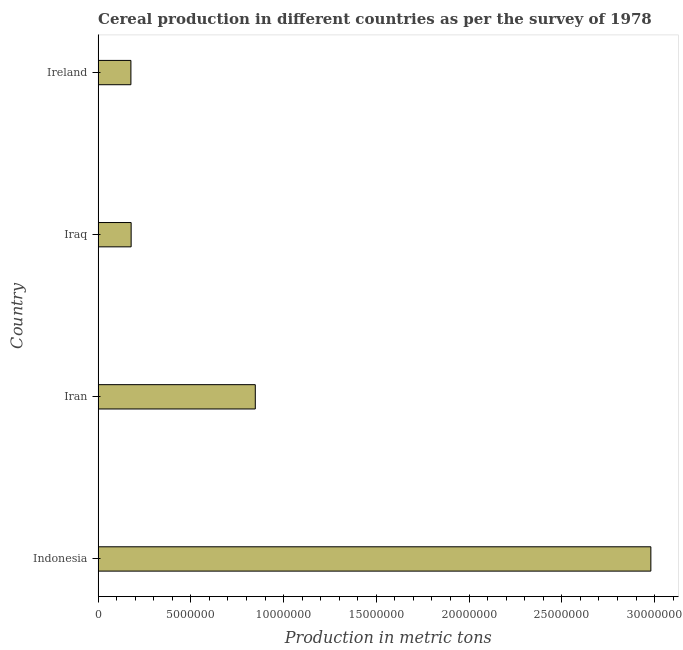Does the graph contain any zero values?
Make the answer very short. No. What is the title of the graph?
Make the answer very short. Cereal production in different countries as per the survey of 1978. What is the label or title of the X-axis?
Make the answer very short. Production in metric tons. What is the label or title of the Y-axis?
Give a very brief answer. Country. What is the cereal production in Ireland?
Offer a very short reply. 1.77e+06. Across all countries, what is the maximum cereal production?
Give a very brief answer. 2.98e+07. Across all countries, what is the minimum cereal production?
Offer a very short reply. 1.77e+06. In which country was the cereal production maximum?
Give a very brief answer. Indonesia. In which country was the cereal production minimum?
Give a very brief answer. Ireland. What is the sum of the cereal production?
Give a very brief answer. 4.18e+07. What is the difference between the cereal production in Iraq and Ireland?
Offer a terse response. 1.25e+04. What is the average cereal production per country?
Your answer should be compact. 1.05e+07. What is the median cereal production?
Offer a terse response. 5.13e+06. In how many countries, is the cereal production greater than 23000000 metric tons?
Ensure brevity in your answer.  1. What is the ratio of the cereal production in Indonesia to that in Iraq?
Ensure brevity in your answer.  16.74. What is the difference between the highest and the second highest cereal production?
Your response must be concise. 2.13e+07. Is the sum of the cereal production in Iran and Iraq greater than the maximum cereal production across all countries?
Your answer should be compact. No. What is the difference between the highest and the lowest cereal production?
Keep it short and to the point. 2.80e+07. What is the difference between two consecutive major ticks on the X-axis?
Your answer should be compact. 5.00e+06. Are the values on the major ticks of X-axis written in scientific E-notation?
Your answer should be compact. No. What is the Production in metric tons of Indonesia?
Your answer should be very brief. 2.98e+07. What is the Production in metric tons of Iran?
Give a very brief answer. 8.47e+06. What is the Production in metric tons of Iraq?
Your response must be concise. 1.78e+06. What is the Production in metric tons in Ireland?
Offer a very short reply. 1.77e+06. What is the difference between the Production in metric tons in Indonesia and Iran?
Offer a very short reply. 2.13e+07. What is the difference between the Production in metric tons in Indonesia and Iraq?
Offer a terse response. 2.80e+07. What is the difference between the Production in metric tons in Indonesia and Ireland?
Give a very brief answer. 2.80e+07. What is the difference between the Production in metric tons in Iran and Iraq?
Your response must be concise. 6.69e+06. What is the difference between the Production in metric tons in Iran and Ireland?
Ensure brevity in your answer.  6.71e+06. What is the difference between the Production in metric tons in Iraq and Ireland?
Your response must be concise. 1.25e+04. What is the ratio of the Production in metric tons in Indonesia to that in Iran?
Offer a very short reply. 3.52. What is the ratio of the Production in metric tons in Indonesia to that in Iraq?
Your response must be concise. 16.74. What is the ratio of the Production in metric tons in Indonesia to that in Ireland?
Make the answer very short. 16.86. What is the ratio of the Production in metric tons in Iran to that in Iraq?
Offer a very short reply. 4.76. What is the ratio of the Production in metric tons in Iran to that in Ireland?
Offer a very short reply. 4.79. What is the ratio of the Production in metric tons in Iraq to that in Ireland?
Make the answer very short. 1.01. 